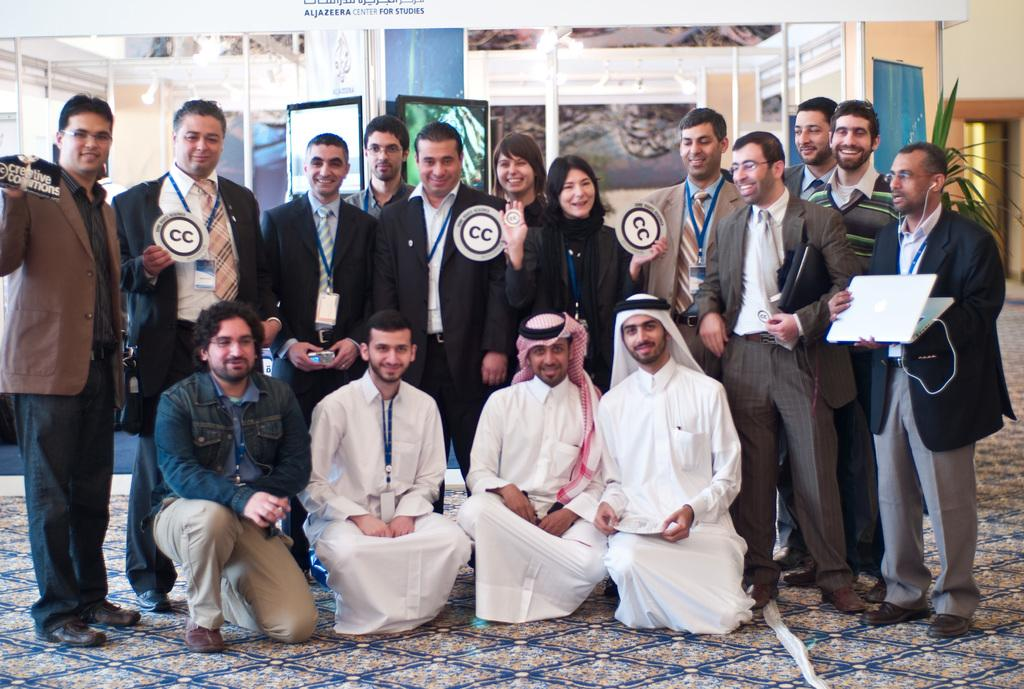How many people are in the image? There is a group of people in the image, but the exact number is not specified. What electronic device can be seen in the image? A laptop is visible in the image. What type of plant is present in the image? There is a plant in the image, but the specific type is not mentioned. What type of structure is visible in the image? Walls are present in the image. What type of display is visible in the image? Screens are visible in the image. What type of vertical support is present in the image? Poles are present in the image. What other objects can be seen in the image? There are some objects in the image, but their specific nature is not mentioned. What is the facial expression of the people in the image? The people in the image are smiling. What type of health record can be seen in the image? There is no health record present in the image. What type of yoke is used by the people in the image? There is no yoke present in the image. 